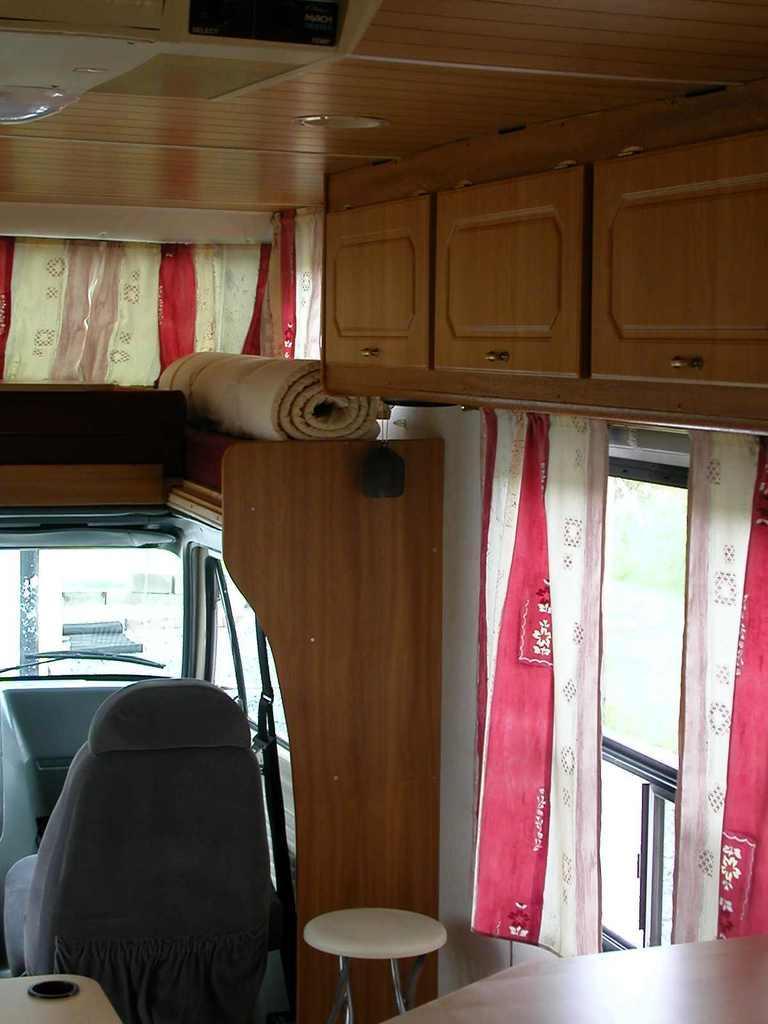How would you summarize this image in a sentence or two? In this image I can see a chair, a stool and a cupboard over here. I can also see curtains on windows. 